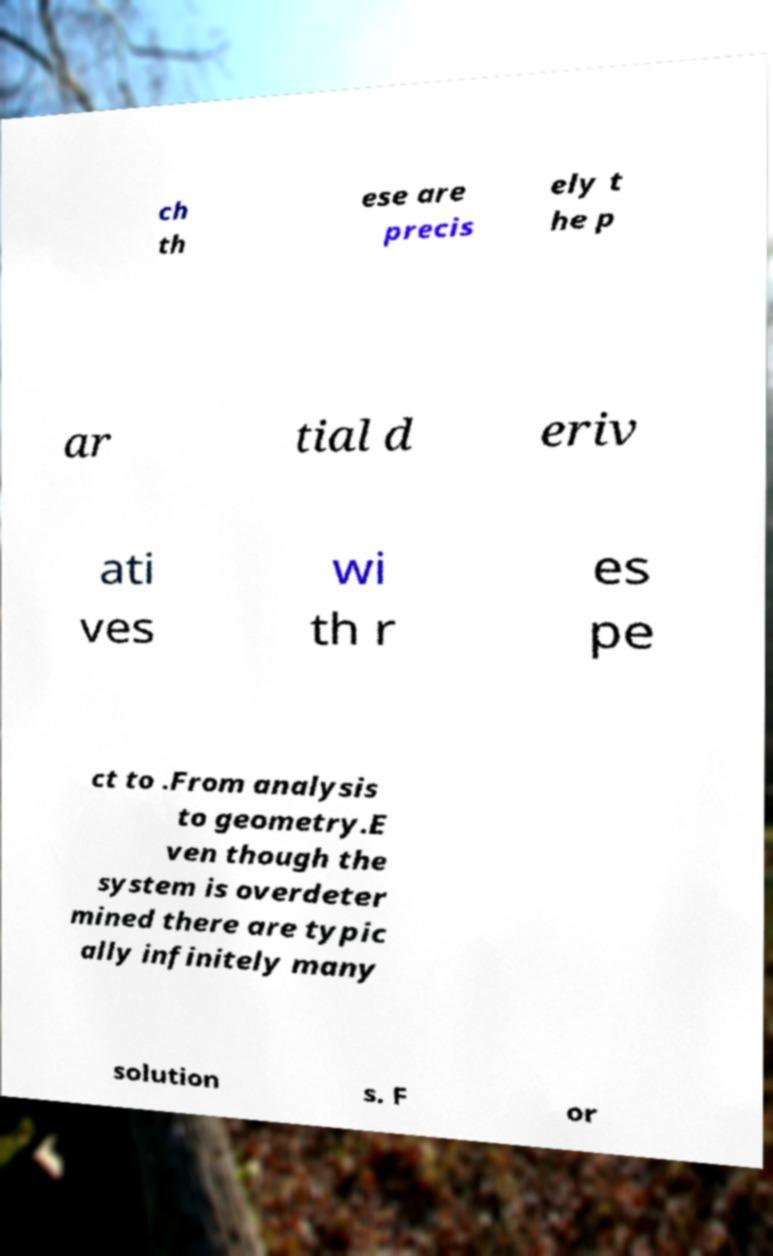Please read and relay the text visible in this image. What does it say? ch th ese are precis ely t he p ar tial d eriv ati ves wi th r es pe ct to .From analysis to geometry.E ven though the system is overdeter mined there are typic ally infinitely many solution s. F or 